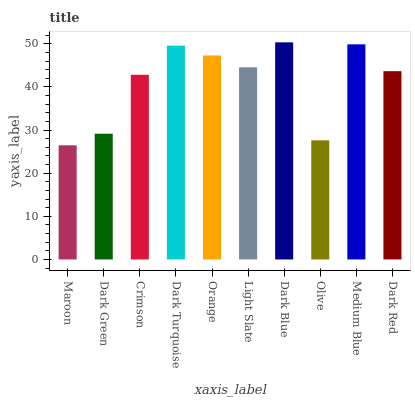Is Maroon the minimum?
Answer yes or no. Yes. Is Dark Blue the maximum?
Answer yes or no. Yes. Is Dark Green the minimum?
Answer yes or no. No. Is Dark Green the maximum?
Answer yes or no. No. Is Dark Green greater than Maroon?
Answer yes or no. Yes. Is Maroon less than Dark Green?
Answer yes or no. Yes. Is Maroon greater than Dark Green?
Answer yes or no. No. Is Dark Green less than Maroon?
Answer yes or no. No. Is Light Slate the high median?
Answer yes or no. Yes. Is Dark Red the low median?
Answer yes or no. Yes. Is Dark Red the high median?
Answer yes or no. No. Is Crimson the low median?
Answer yes or no. No. 